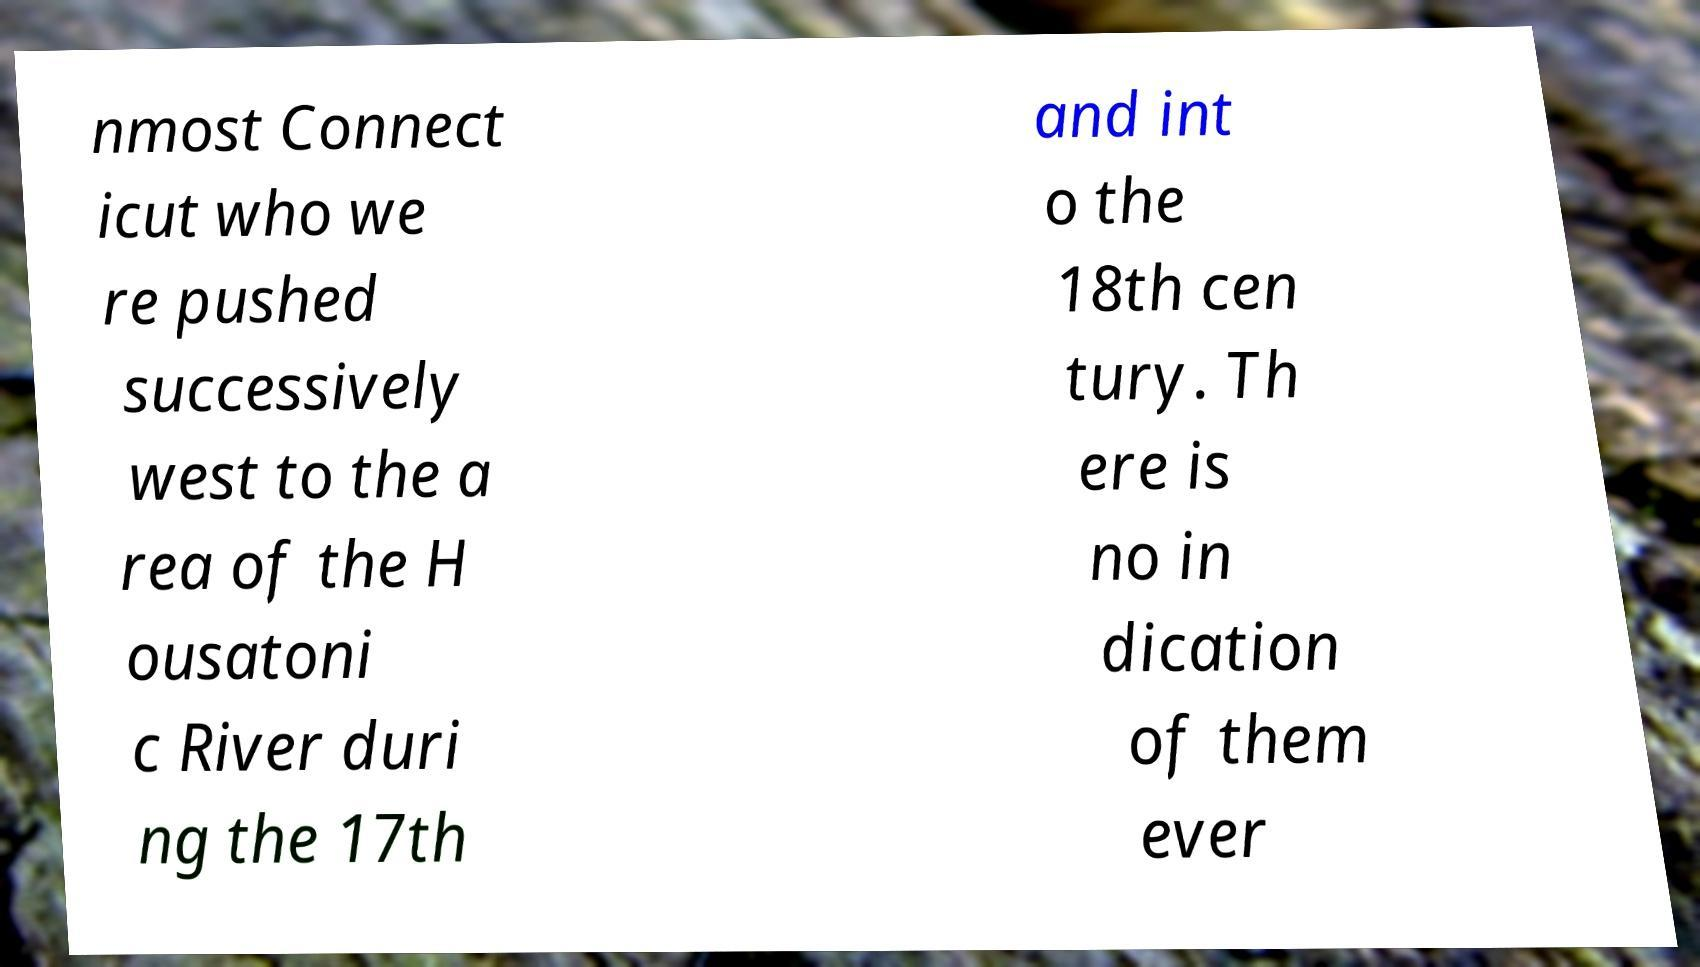Can you accurately transcribe the text from the provided image for me? nmost Connect icut who we re pushed successively west to the a rea of the H ousatoni c River duri ng the 17th and int o the 18th cen tury. Th ere is no in dication of them ever 